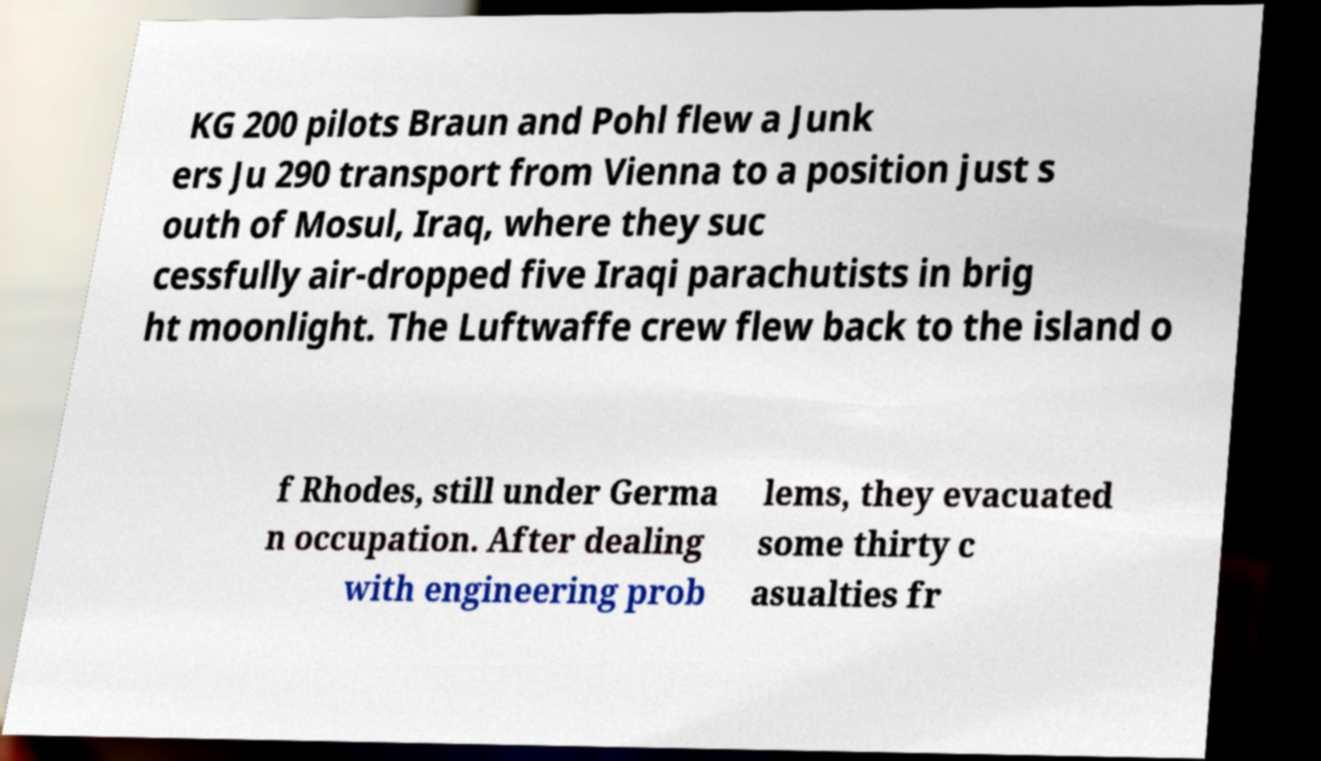Can you accurately transcribe the text from the provided image for me? KG 200 pilots Braun and Pohl flew a Junk ers Ju 290 transport from Vienna to a position just s outh of Mosul, Iraq, where they suc cessfully air-dropped five Iraqi parachutists in brig ht moonlight. The Luftwaffe crew flew back to the island o f Rhodes, still under Germa n occupation. After dealing with engineering prob lems, they evacuated some thirty c asualties fr 